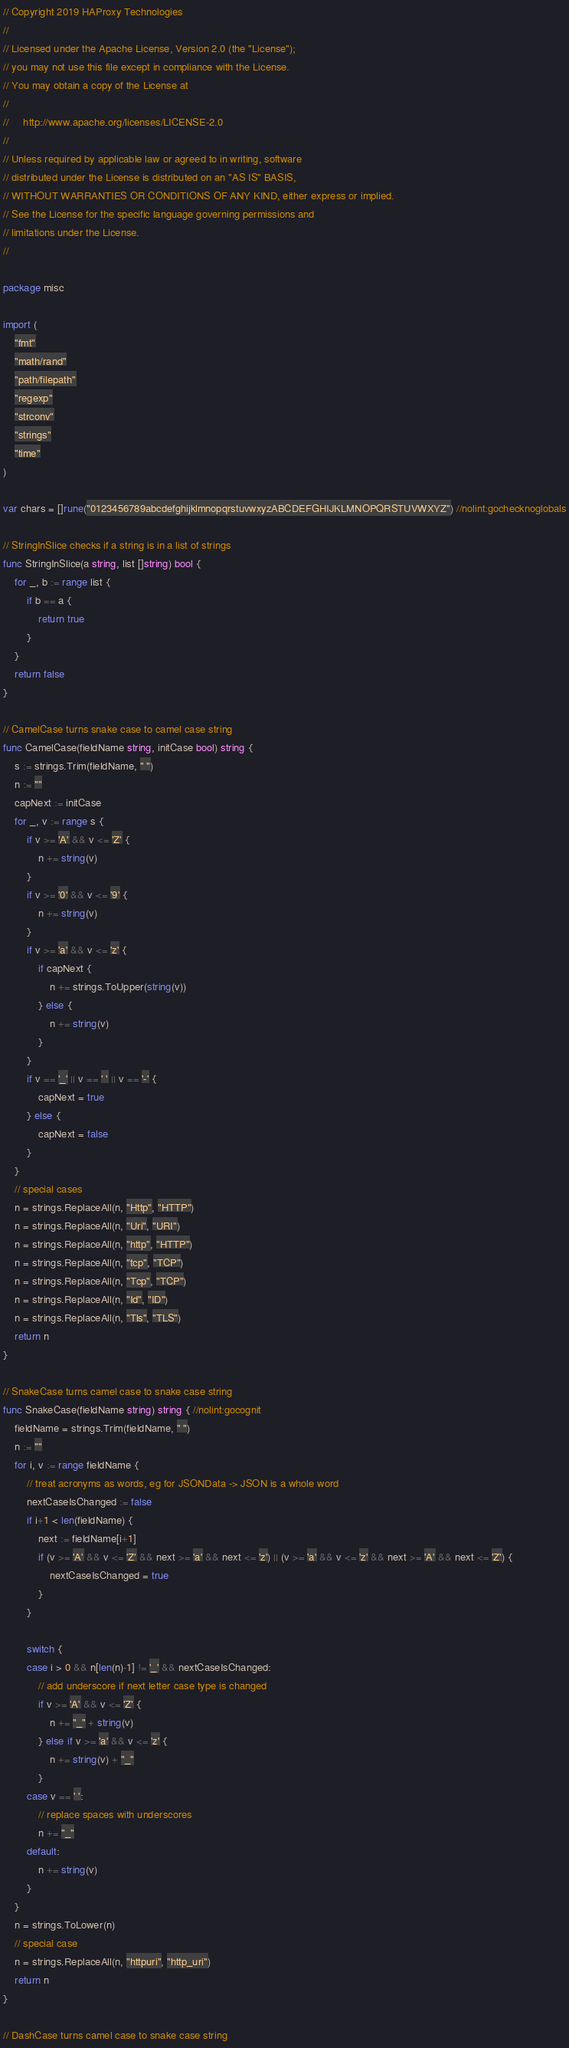<code> <loc_0><loc_0><loc_500><loc_500><_Go_>// Copyright 2019 HAProxy Technologies
//
// Licensed under the Apache License, Version 2.0 (the "License");
// you may not use this file except in compliance with the License.
// You may obtain a copy of the License at
//
//     http://www.apache.org/licenses/LICENSE-2.0
//
// Unless required by applicable law or agreed to in writing, software
// distributed under the License is distributed on an "AS IS" BASIS,
// WITHOUT WARRANTIES OR CONDITIONS OF ANY KIND, either express or implied.
// See the License for the specific language governing permissions and
// limitations under the License.
//

package misc

import (
	"fmt"
	"math/rand"
	"path/filepath"
	"regexp"
	"strconv"
	"strings"
	"time"
)

var chars = []rune("0123456789abcdefghijklmnopqrstuvwxyzABCDEFGHIJKLMNOPQRSTUVWXYZ") //nolint:gochecknoglobals

// StringInSlice checks if a string is in a list of strings
func StringInSlice(a string, list []string) bool {
	for _, b := range list {
		if b == a {
			return true
		}
	}
	return false
}

// CamelCase turns snake case to camel case string
func CamelCase(fieldName string, initCase bool) string {
	s := strings.Trim(fieldName, " ")
	n := ""
	capNext := initCase
	for _, v := range s {
		if v >= 'A' && v <= 'Z' {
			n += string(v)
		}
		if v >= '0' && v <= '9' {
			n += string(v)
		}
		if v >= 'a' && v <= 'z' {
			if capNext {
				n += strings.ToUpper(string(v))
			} else {
				n += string(v)
			}
		}
		if v == '_' || v == ' ' || v == '-' {
			capNext = true
		} else {
			capNext = false
		}
	}
	// special cases
	n = strings.ReplaceAll(n, "Http", "HTTP")
	n = strings.ReplaceAll(n, "Uri", "URI")
	n = strings.ReplaceAll(n, "http", "HTTP")
	n = strings.ReplaceAll(n, "tcp", "TCP")
	n = strings.ReplaceAll(n, "Tcp", "TCP")
	n = strings.ReplaceAll(n, "Id", "ID")
	n = strings.ReplaceAll(n, "Tls", "TLS")
	return n
}

// SnakeCase turns camel case to snake case string
func SnakeCase(fieldName string) string { //nolint:gocognit
	fieldName = strings.Trim(fieldName, " ")
	n := ""
	for i, v := range fieldName {
		// treat acronyms as words, eg for JSONData -> JSON is a whole word
		nextCaseIsChanged := false
		if i+1 < len(fieldName) {
			next := fieldName[i+1]
			if (v >= 'A' && v <= 'Z' && next >= 'a' && next <= 'z') || (v >= 'a' && v <= 'z' && next >= 'A' && next <= 'Z') {
				nextCaseIsChanged = true
			}
		}

		switch {
		case i > 0 && n[len(n)-1] != '_' && nextCaseIsChanged:
			// add underscore if next letter case type is changed
			if v >= 'A' && v <= 'Z' {
				n += "_" + string(v)
			} else if v >= 'a' && v <= 'z' {
				n += string(v) + "_"
			}
		case v == ' ':
			// replace spaces with underscores
			n += "_"
		default:
			n += string(v)
		}
	}
	n = strings.ToLower(n)
	// special case
	n = strings.ReplaceAll(n, "httpuri", "http_uri")
	return n
}

// DashCase turns camel case to snake case string</code> 